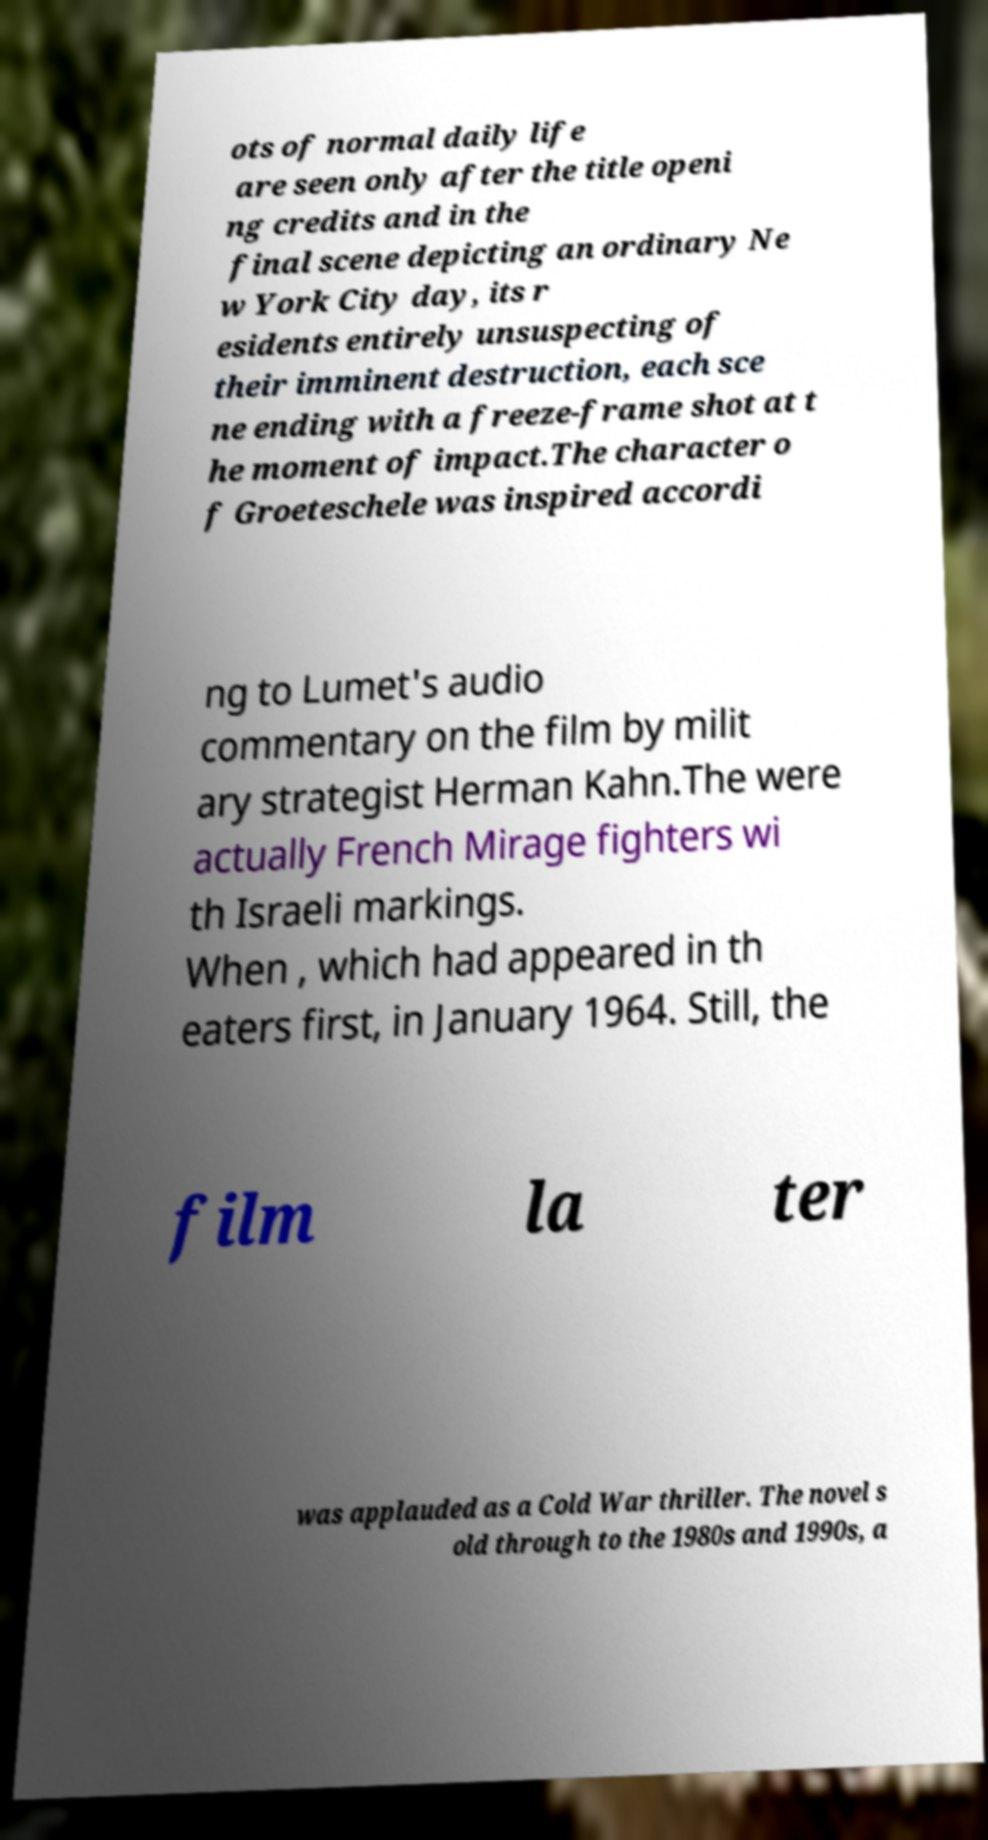Can you read and provide the text displayed in the image?This photo seems to have some interesting text. Can you extract and type it out for me? ots of normal daily life are seen only after the title openi ng credits and in the final scene depicting an ordinary Ne w York City day, its r esidents entirely unsuspecting of their imminent destruction, each sce ne ending with a freeze-frame shot at t he moment of impact.The character o f Groeteschele was inspired accordi ng to Lumet's audio commentary on the film by milit ary strategist Herman Kahn.The were actually French Mirage fighters wi th Israeli markings. When , which had appeared in th eaters first, in January 1964. Still, the film la ter was applauded as a Cold War thriller. The novel s old through to the 1980s and 1990s, a 